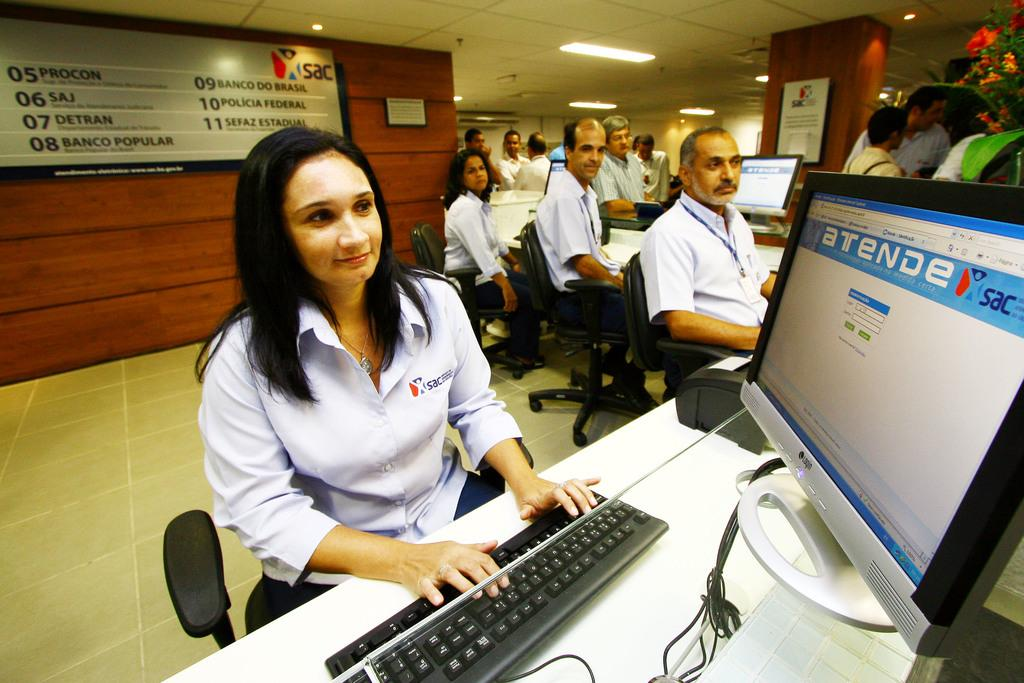<image>
Present a compact description of the photo's key features. Woman using a computer with the monitor saying "atende". 